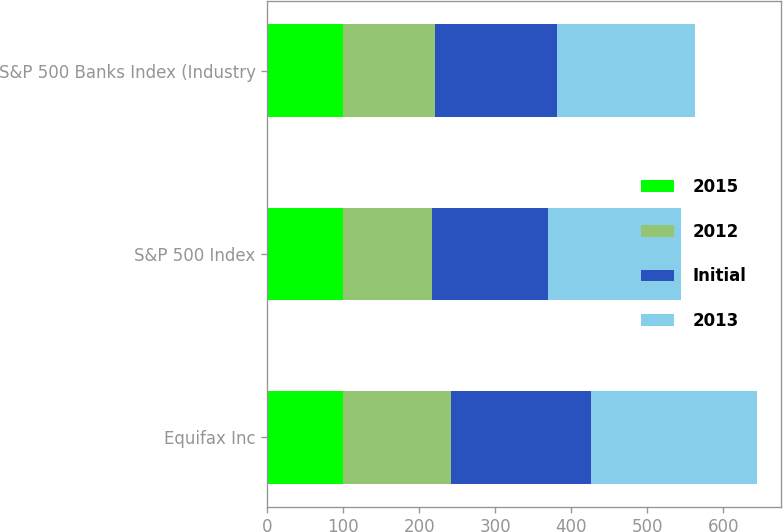<chart> <loc_0><loc_0><loc_500><loc_500><stacked_bar_chart><ecel><fcel>Equifax Inc<fcel>S&P 500 Index<fcel>S&P 500 Banks Index (Industry<nl><fcel>2015<fcel>100<fcel>100<fcel>100<nl><fcel>2012<fcel>141.91<fcel>116<fcel>121.19<nl><fcel>Initial<fcel>183.8<fcel>153.57<fcel>160.27<nl><fcel>2013<fcel>218.08<fcel>174.59<fcel>181.52<nl></chart> 